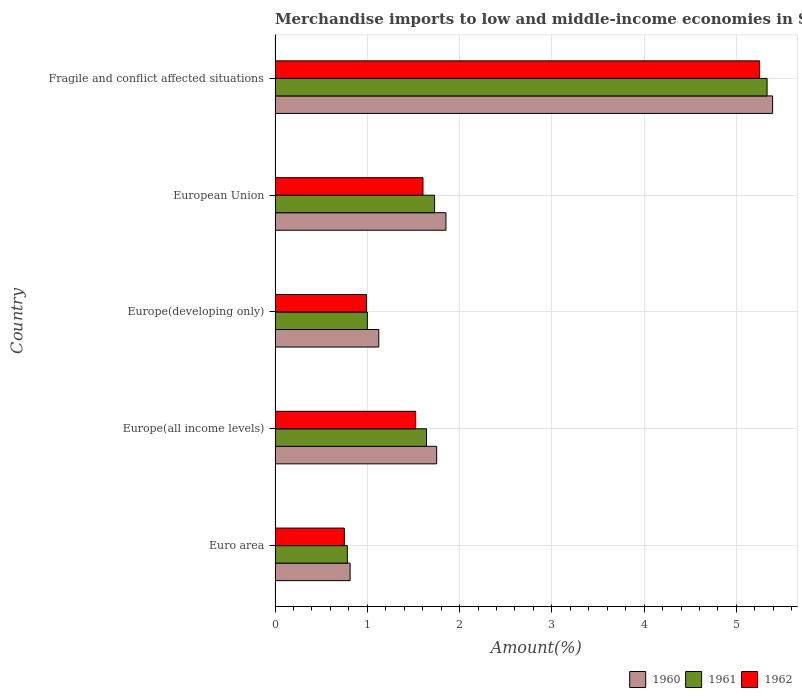How many different coloured bars are there?
Offer a terse response. 3. Are the number of bars per tick equal to the number of legend labels?
Ensure brevity in your answer.  Yes. What is the label of the 5th group of bars from the top?
Keep it short and to the point. Euro area. What is the percentage of amount earned from merchandise imports in 1960 in Euro area?
Provide a short and direct response. 0.81. Across all countries, what is the maximum percentage of amount earned from merchandise imports in 1961?
Offer a very short reply. 5.33. Across all countries, what is the minimum percentage of amount earned from merchandise imports in 1960?
Ensure brevity in your answer.  0.81. In which country was the percentage of amount earned from merchandise imports in 1960 maximum?
Give a very brief answer. Fragile and conflict affected situations. What is the total percentage of amount earned from merchandise imports in 1961 in the graph?
Provide a succinct answer. 10.49. What is the difference between the percentage of amount earned from merchandise imports in 1962 in Euro area and that in Europe(all income levels)?
Your answer should be very brief. -0.77. What is the difference between the percentage of amount earned from merchandise imports in 1960 in Euro area and the percentage of amount earned from merchandise imports in 1962 in European Union?
Provide a succinct answer. -0.79. What is the average percentage of amount earned from merchandise imports in 1962 per country?
Provide a short and direct response. 2.02. What is the difference between the percentage of amount earned from merchandise imports in 1960 and percentage of amount earned from merchandise imports in 1961 in Europe(developing only)?
Your answer should be compact. 0.12. What is the ratio of the percentage of amount earned from merchandise imports in 1961 in Europe(all income levels) to that in Europe(developing only)?
Your response must be concise. 1.64. Is the difference between the percentage of amount earned from merchandise imports in 1960 in European Union and Fragile and conflict affected situations greater than the difference between the percentage of amount earned from merchandise imports in 1961 in European Union and Fragile and conflict affected situations?
Give a very brief answer. Yes. What is the difference between the highest and the second highest percentage of amount earned from merchandise imports in 1961?
Offer a very short reply. 3.6. What is the difference between the highest and the lowest percentage of amount earned from merchandise imports in 1960?
Provide a short and direct response. 4.58. In how many countries, is the percentage of amount earned from merchandise imports in 1960 greater than the average percentage of amount earned from merchandise imports in 1960 taken over all countries?
Your response must be concise. 1. What does the 1st bar from the bottom in Europe(developing only) represents?
Provide a short and direct response. 1960. How many countries are there in the graph?
Your response must be concise. 5. What is the difference between two consecutive major ticks on the X-axis?
Provide a short and direct response. 1. Are the values on the major ticks of X-axis written in scientific E-notation?
Make the answer very short. No. Does the graph contain grids?
Provide a succinct answer. Yes. What is the title of the graph?
Give a very brief answer. Merchandise imports to low and middle-income economies in South Asia. Does "1960" appear as one of the legend labels in the graph?
Provide a succinct answer. Yes. What is the label or title of the X-axis?
Give a very brief answer. Amount(%). What is the Amount(%) in 1960 in Euro area?
Keep it short and to the point. 0.81. What is the Amount(%) of 1961 in Euro area?
Provide a succinct answer. 0.78. What is the Amount(%) of 1962 in Euro area?
Provide a succinct answer. 0.75. What is the Amount(%) in 1960 in Europe(all income levels)?
Provide a short and direct response. 1.75. What is the Amount(%) in 1961 in Europe(all income levels)?
Make the answer very short. 1.64. What is the Amount(%) of 1962 in Europe(all income levels)?
Your answer should be compact. 1.52. What is the Amount(%) of 1960 in Europe(developing only)?
Provide a succinct answer. 1.12. What is the Amount(%) in 1961 in Europe(developing only)?
Make the answer very short. 1. What is the Amount(%) of 1962 in Europe(developing only)?
Make the answer very short. 0.99. What is the Amount(%) of 1960 in European Union?
Offer a terse response. 1.85. What is the Amount(%) in 1961 in European Union?
Make the answer very short. 1.73. What is the Amount(%) in 1962 in European Union?
Your answer should be compact. 1.6. What is the Amount(%) in 1960 in Fragile and conflict affected situations?
Your answer should be very brief. 5.39. What is the Amount(%) of 1961 in Fragile and conflict affected situations?
Offer a very short reply. 5.33. What is the Amount(%) of 1962 in Fragile and conflict affected situations?
Your answer should be compact. 5.25. Across all countries, what is the maximum Amount(%) in 1960?
Make the answer very short. 5.39. Across all countries, what is the maximum Amount(%) in 1961?
Give a very brief answer. 5.33. Across all countries, what is the maximum Amount(%) of 1962?
Keep it short and to the point. 5.25. Across all countries, what is the minimum Amount(%) in 1960?
Provide a succinct answer. 0.81. Across all countries, what is the minimum Amount(%) in 1961?
Ensure brevity in your answer.  0.78. Across all countries, what is the minimum Amount(%) in 1962?
Your response must be concise. 0.75. What is the total Amount(%) in 1960 in the graph?
Offer a terse response. 10.93. What is the total Amount(%) of 1961 in the graph?
Ensure brevity in your answer.  10.49. What is the total Amount(%) in 1962 in the graph?
Your answer should be compact. 10.12. What is the difference between the Amount(%) in 1960 in Euro area and that in Europe(all income levels)?
Make the answer very short. -0.94. What is the difference between the Amount(%) of 1961 in Euro area and that in Europe(all income levels)?
Your answer should be very brief. -0.86. What is the difference between the Amount(%) in 1962 in Euro area and that in Europe(all income levels)?
Make the answer very short. -0.77. What is the difference between the Amount(%) of 1960 in Euro area and that in Europe(developing only)?
Your answer should be compact. -0.31. What is the difference between the Amount(%) in 1961 in Euro area and that in Europe(developing only)?
Offer a very short reply. -0.22. What is the difference between the Amount(%) of 1962 in Euro area and that in Europe(developing only)?
Offer a very short reply. -0.24. What is the difference between the Amount(%) of 1960 in Euro area and that in European Union?
Offer a very short reply. -1.04. What is the difference between the Amount(%) in 1961 in Euro area and that in European Union?
Ensure brevity in your answer.  -0.95. What is the difference between the Amount(%) of 1962 in Euro area and that in European Union?
Your response must be concise. -0.85. What is the difference between the Amount(%) of 1960 in Euro area and that in Fragile and conflict affected situations?
Your answer should be compact. -4.58. What is the difference between the Amount(%) in 1961 in Euro area and that in Fragile and conflict affected situations?
Provide a succinct answer. -4.55. What is the difference between the Amount(%) in 1962 in Euro area and that in Fragile and conflict affected situations?
Your answer should be very brief. -4.5. What is the difference between the Amount(%) in 1960 in Europe(all income levels) and that in Europe(developing only)?
Offer a very short reply. 0.63. What is the difference between the Amount(%) of 1961 in Europe(all income levels) and that in Europe(developing only)?
Offer a terse response. 0.64. What is the difference between the Amount(%) in 1962 in Europe(all income levels) and that in Europe(developing only)?
Make the answer very short. 0.53. What is the difference between the Amount(%) in 1960 in Europe(all income levels) and that in European Union?
Provide a short and direct response. -0.1. What is the difference between the Amount(%) in 1961 in Europe(all income levels) and that in European Union?
Provide a succinct answer. -0.09. What is the difference between the Amount(%) of 1962 in Europe(all income levels) and that in European Union?
Your answer should be very brief. -0.08. What is the difference between the Amount(%) of 1960 in Europe(all income levels) and that in Fragile and conflict affected situations?
Your response must be concise. -3.64. What is the difference between the Amount(%) in 1961 in Europe(all income levels) and that in Fragile and conflict affected situations?
Ensure brevity in your answer.  -3.69. What is the difference between the Amount(%) of 1962 in Europe(all income levels) and that in Fragile and conflict affected situations?
Your answer should be compact. -3.73. What is the difference between the Amount(%) in 1960 in Europe(developing only) and that in European Union?
Provide a succinct answer. -0.73. What is the difference between the Amount(%) of 1961 in Europe(developing only) and that in European Union?
Make the answer very short. -0.73. What is the difference between the Amount(%) in 1962 in Europe(developing only) and that in European Union?
Offer a terse response. -0.61. What is the difference between the Amount(%) of 1960 in Europe(developing only) and that in Fragile and conflict affected situations?
Your response must be concise. -4.27. What is the difference between the Amount(%) in 1961 in Europe(developing only) and that in Fragile and conflict affected situations?
Your answer should be compact. -4.33. What is the difference between the Amount(%) in 1962 in Europe(developing only) and that in Fragile and conflict affected situations?
Your answer should be compact. -4.26. What is the difference between the Amount(%) of 1960 in European Union and that in Fragile and conflict affected situations?
Ensure brevity in your answer.  -3.54. What is the difference between the Amount(%) of 1961 in European Union and that in Fragile and conflict affected situations?
Your answer should be very brief. -3.6. What is the difference between the Amount(%) in 1962 in European Union and that in Fragile and conflict affected situations?
Ensure brevity in your answer.  -3.65. What is the difference between the Amount(%) of 1960 in Euro area and the Amount(%) of 1961 in Europe(all income levels)?
Make the answer very short. -0.83. What is the difference between the Amount(%) in 1960 in Euro area and the Amount(%) in 1962 in Europe(all income levels)?
Keep it short and to the point. -0.71. What is the difference between the Amount(%) of 1961 in Euro area and the Amount(%) of 1962 in Europe(all income levels)?
Give a very brief answer. -0.74. What is the difference between the Amount(%) in 1960 in Euro area and the Amount(%) in 1961 in Europe(developing only)?
Provide a short and direct response. -0.19. What is the difference between the Amount(%) in 1960 in Euro area and the Amount(%) in 1962 in Europe(developing only)?
Keep it short and to the point. -0.18. What is the difference between the Amount(%) in 1961 in Euro area and the Amount(%) in 1962 in Europe(developing only)?
Offer a terse response. -0.21. What is the difference between the Amount(%) of 1960 in Euro area and the Amount(%) of 1961 in European Union?
Provide a succinct answer. -0.92. What is the difference between the Amount(%) in 1960 in Euro area and the Amount(%) in 1962 in European Union?
Provide a short and direct response. -0.79. What is the difference between the Amount(%) of 1961 in Euro area and the Amount(%) of 1962 in European Union?
Provide a succinct answer. -0.82. What is the difference between the Amount(%) in 1960 in Euro area and the Amount(%) in 1961 in Fragile and conflict affected situations?
Give a very brief answer. -4.52. What is the difference between the Amount(%) in 1960 in Euro area and the Amount(%) in 1962 in Fragile and conflict affected situations?
Provide a succinct answer. -4.44. What is the difference between the Amount(%) in 1961 in Euro area and the Amount(%) in 1962 in Fragile and conflict affected situations?
Keep it short and to the point. -4.47. What is the difference between the Amount(%) of 1960 in Europe(all income levels) and the Amount(%) of 1961 in Europe(developing only)?
Keep it short and to the point. 0.75. What is the difference between the Amount(%) in 1960 in Europe(all income levels) and the Amount(%) in 1962 in Europe(developing only)?
Ensure brevity in your answer.  0.76. What is the difference between the Amount(%) of 1961 in Europe(all income levels) and the Amount(%) of 1962 in Europe(developing only)?
Ensure brevity in your answer.  0.65. What is the difference between the Amount(%) in 1960 in Europe(all income levels) and the Amount(%) in 1961 in European Union?
Offer a terse response. 0.02. What is the difference between the Amount(%) of 1960 in Europe(all income levels) and the Amount(%) of 1962 in European Union?
Provide a succinct answer. 0.15. What is the difference between the Amount(%) in 1961 in Europe(all income levels) and the Amount(%) in 1962 in European Union?
Provide a succinct answer. 0.04. What is the difference between the Amount(%) in 1960 in Europe(all income levels) and the Amount(%) in 1961 in Fragile and conflict affected situations?
Ensure brevity in your answer.  -3.58. What is the difference between the Amount(%) in 1960 in Europe(all income levels) and the Amount(%) in 1962 in Fragile and conflict affected situations?
Your answer should be very brief. -3.5. What is the difference between the Amount(%) in 1961 in Europe(all income levels) and the Amount(%) in 1962 in Fragile and conflict affected situations?
Offer a very short reply. -3.61. What is the difference between the Amount(%) of 1960 in Europe(developing only) and the Amount(%) of 1961 in European Union?
Your answer should be very brief. -0.61. What is the difference between the Amount(%) in 1960 in Europe(developing only) and the Amount(%) in 1962 in European Union?
Keep it short and to the point. -0.48. What is the difference between the Amount(%) in 1961 in Europe(developing only) and the Amount(%) in 1962 in European Union?
Ensure brevity in your answer.  -0.6. What is the difference between the Amount(%) in 1960 in Europe(developing only) and the Amount(%) in 1961 in Fragile and conflict affected situations?
Offer a very short reply. -4.21. What is the difference between the Amount(%) of 1960 in Europe(developing only) and the Amount(%) of 1962 in Fragile and conflict affected situations?
Give a very brief answer. -4.13. What is the difference between the Amount(%) of 1961 in Europe(developing only) and the Amount(%) of 1962 in Fragile and conflict affected situations?
Provide a succinct answer. -4.25. What is the difference between the Amount(%) of 1960 in European Union and the Amount(%) of 1961 in Fragile and conflict affected situations?
Provide a short and direct response. -3.48. What is the difference between the Amount(%) of 1960 in European Union and the Amount(%) of 1962 in Fragile and conflict affected situations?
Offer a very short reply. -3.4. What is the difference between the Amount(%) of 1961 in European Union and the Amount(%) of 1962 in Fragile and conflict affected situations?
Offer a terse response. -3.52. What is the average Amount(%) of 1960 per country?
Your answer should be very brief. 2.19. What is the average Amount(%) of 1961 per country?
Keep it short and to the point. 2.1. What is the average Amount(%) in 1962 per country?
Keep it short and to the point. 2.02. What is the difference between the Amount(%) in 1960 and Amount(%) in 1961 in Euro area?
Provide a short and direct response. 0.03. What is the difference between the Amount(%) in 1960 and Amount(%) in 1962 in Euro area?
Provide a short and direct response. 0.06. What is the difference between the Amount(%) in 1961 and Amount(%) in 1962 in Euro area?
Your answer should be very brief. 0.03. What is the difference between the Amount(%) in 1960 and Amount(%) in 1961 in Europe(all income levels)?
Your answer should be compact. 0.11. What is the difference between the Amount(%) of 1960 and Amount(%) of 1962 in Europe(all income levels)?
Offer a very short reply. 0.23. What is the difference between the Amount(%) in 1961 and Amount(%) in 1962 in Europe(all income levels)?
Offer a very short reply. 0.12. What is the difference between the Amount(%) of 1960 and Amount(%) of 1961 in Europe(developing only)?
Provide a succinct answer. 0.12. What is the difference between the Amount(%) in 1960 and Amount(%) in 1962 in Europe(developing only)?
Offer a very short reply. 0.13. What is the difference between the Amount(%) in 1961 and Amount(%) in 1962 in Europe(developing only)?
Give a very brief answer. 0.01. What is the difference between the Amount(%) of 1960 and Amount(%) of 1961 in European Union?
Your answer should be compact. 0.12. What is the difference between the Amount(%) in 1960 and Amount(%) in 1962 in European Union?
Provide a succinct answer. 0.25. What is the difference between the Amount(%) in 1961 and Amount(%) in 1962 in European Union?
Offer a very short reply. 0.13. What is the difference between the Amount(%) of 1960 and Amount(%) of 1961 in Fragile and conflict affected situations?
Keep it short and to the point. 0.06. What is the difference between the Amount(%) of 1960 and Amount(%) of 1962 in Fragile and conflict affected situations?
Offer a terse response. 0.14. What is the difference between the Amount(%) in 1961 and Amount(%) in 1962 in Fragile and conflict affected situations?
Give a very brief answer. 0.08. What is the ratio of the Amount(%) of 1960 in Euro area to that in Europe(all income levels)?
Offer a terse response. 0.46. What is the ratio of the Amount(%) in 1961 in Euro area to that in Europe(all income levels)?
Your response must be concise. 0.48. What is the ratio of the Amount(%) in 1962 in Euro area to that in Europe(all income levels)?
Make the answer very short. 0.49. What is the ratio of the Amount(%) of 1960 in Euro area to that in Europe(developing only)?
Provide a succinct answer. 0.72. What is the ratio of the Amount(%) in 1961 in Euro area to that in Europe(developing only)?
Ensure brevity in your answer.  0.78. What is the ratio of the Amount(%) in 1962 in Euro area to that in Europe(developing only)?
Provide a succinct answer. 0.76. What is the ratio of the Amount(%) in 1960 in Euro area to that in European Union?
Make the answer very short. 0.44. What is the ratio of the Amount(%) of 1961 in Euro area to that in European Union?
Provide a succinct answer. 0.45. What is the ratio of the Amount(%) of 1962 in Euro area to that in European Union?
Your answer should be compact. 0.47. What is the ratio of the Amount(%) in 1960 in Euro area to that in Fragile and conflict affected situations?
Keep it short and to the point. 0.15. What is the ratio of the Amount(%) of 1961 in Euro area to that in Fragile and conflict affected situations?
Give a very brief answer. 0.15. What is the ratio of the Amount(%) in 1962 in Euro area to that in Fragile and conflict affected situations?
Provide a succinct answer. 0.14. What is the ratio of the Amount(%) in 1960 in Europe(all income levels) to that in Europe(developing only)?
Keep it short and to the point. 1.56. What is the ratio of the Amount(%) of 1961 in Europe(all income levels) to that in Europe(developing only)?
Provide a succinct answer. 1.64. What is the ratio of the Amount(%) of 1962 in Europe(all income levels) to that in Europe(developing only)?
Your answer should be compact. 1.54. What is the ratio of the Amount(%) of 1960 in Europe(all income levels) to that in European Union?
Ensure brevity in your answer.  0.95. What is the ratio of the Amount(%) of 1961 in Europe(all income levels) to that in European Union?
Offer a very short reply. 0.95. What is the ratio of the Amount(%) of 1962 in Europe(all income levels) to that in European Union?
Your answer should be compact. 0.95. What is the ratio of the Amount(%) in 1960 in Europe(all income levels) to that in Fragile and conflict affected situations?
Your answer should be very brief. 0.32. What is the ratio of the Amount(%) of 1961 in Europe(all income levels) to that in Fragile and conflict affected situations?
Your answer should be compact. 0.31. What is the ratio of the Amount(%) in 1962 in Europe(all income levels) to that in Fragile and conflict affected situations?
Your answer should be very brief. 0.29. What is the ratio of the Amount(%) in 1960 in Europe(developing only) to that in European Union?
Provide a short and direct response. 0.61. What is the ratio of the Amount(%) in 1961 in Europe(developing only) to that in European Union?
Offer a terse response. 0.58. What is the ratio of the Amount(%) in 1962 in Europe(developing only) to that in European Union?
Provide a short and direct response. 0.62. What is the ratio of the Amount(%) in 1960 in Europe(developing only) to that in Fragile and conflict affected situations?
Give a very brief answer. 0.21. What is the ratio of the Amount(%) of 1961 in Europe(developing only) to that in Fragile and conflict affected situations?
Ensure brevity in your answer.  0.19. What is the ratio of the Amount(%) of 1962 in Europe(developing only) to that in Fragile and conflict affected situations?
Keep it short and to the point. 0.19. What is the ratio of the Amount(%) in 1960 in European Union to that in Fragile and conflict affected situations?
Give a very brief answer. 0.34. What is the ratio of the Amount(%) of 1961 in European Union to that in Fragile and conflict affected situations?
Give a very brief answer. 0.32. What is the ratio of the Amount(%) in 1962 in European Union to that in Fragile and conflict affected situations?
Your answer should be very brief. 0.31. What is the difference between the highest and the second highest Amount(%) of 1960?
Offer a very short reply. 3.54. What is the difference between the highest and the second highest Amount(%) of 1961?
Your response must be concise. 3.6. What is the difference between the highest and the second highest Amount(%) of 1962?
Make the answer very short. 3.65. What is the difference between the highest and the lowest Amount(%) in 1960?
Make the answer very short. 4.58. What is the difference between the highest and the lowest Amount(%) in 1961?
Offer a very short reply. 4.55. What is the difference between the highest and the lowest Amount(%) of 1962?
Provide a short and direct response. 4.5. 